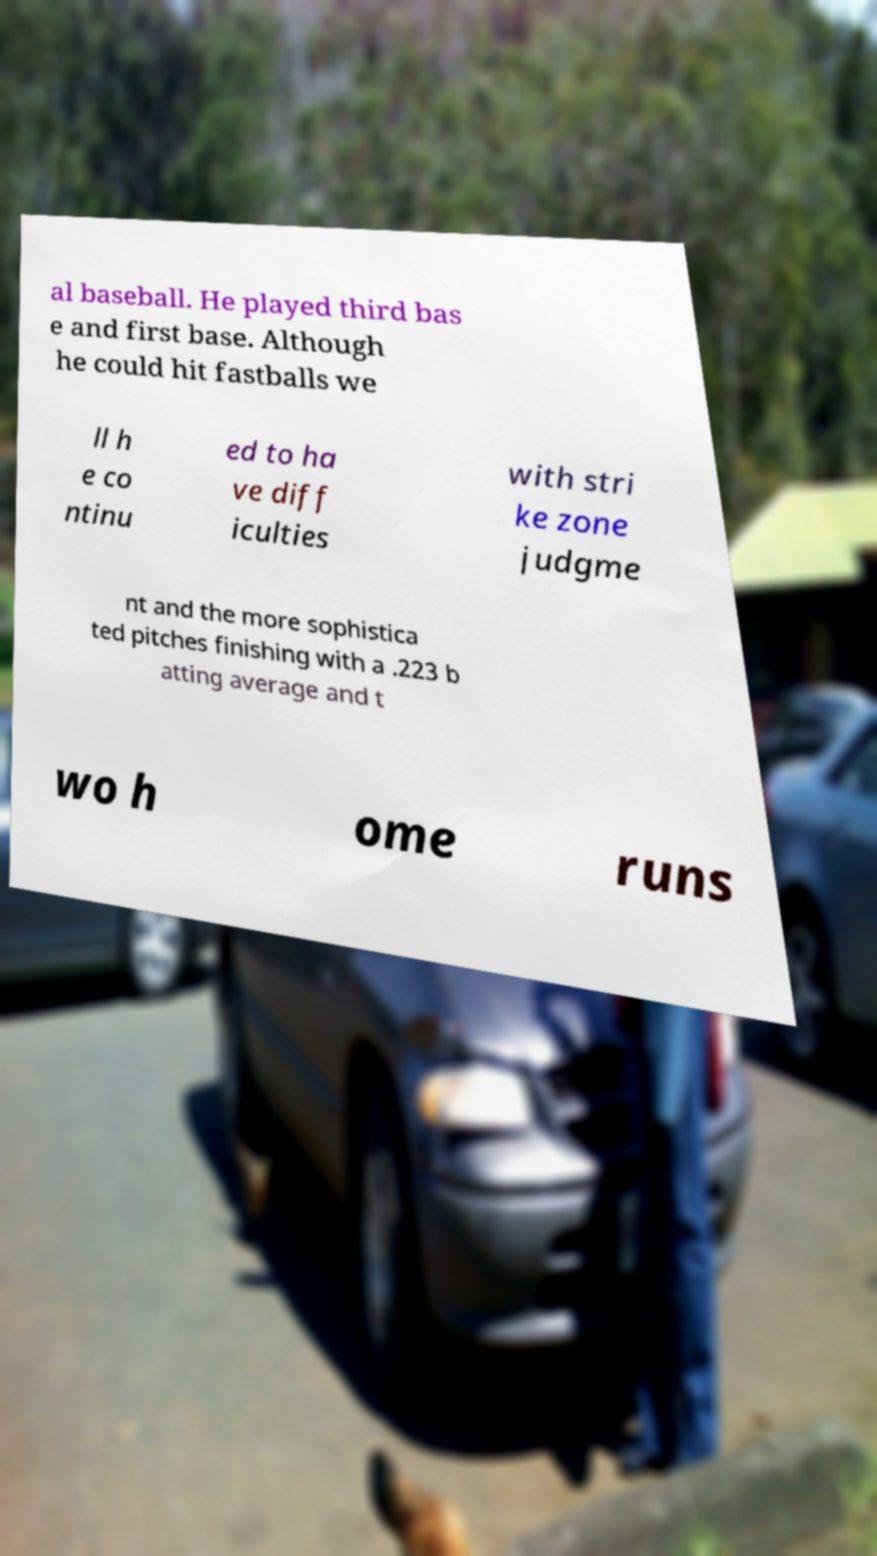What messages or text are displayed in this image? I need them in a readable, typed format. al baseball. He played third bas e and first base. Although he could hit fastballs we ll h e co ntinu ed to ha ve diff iculties with stri ke zone judgme nt and the more sophistica ted pitches finishing with a .223 b atting average and t wo h ome runs 